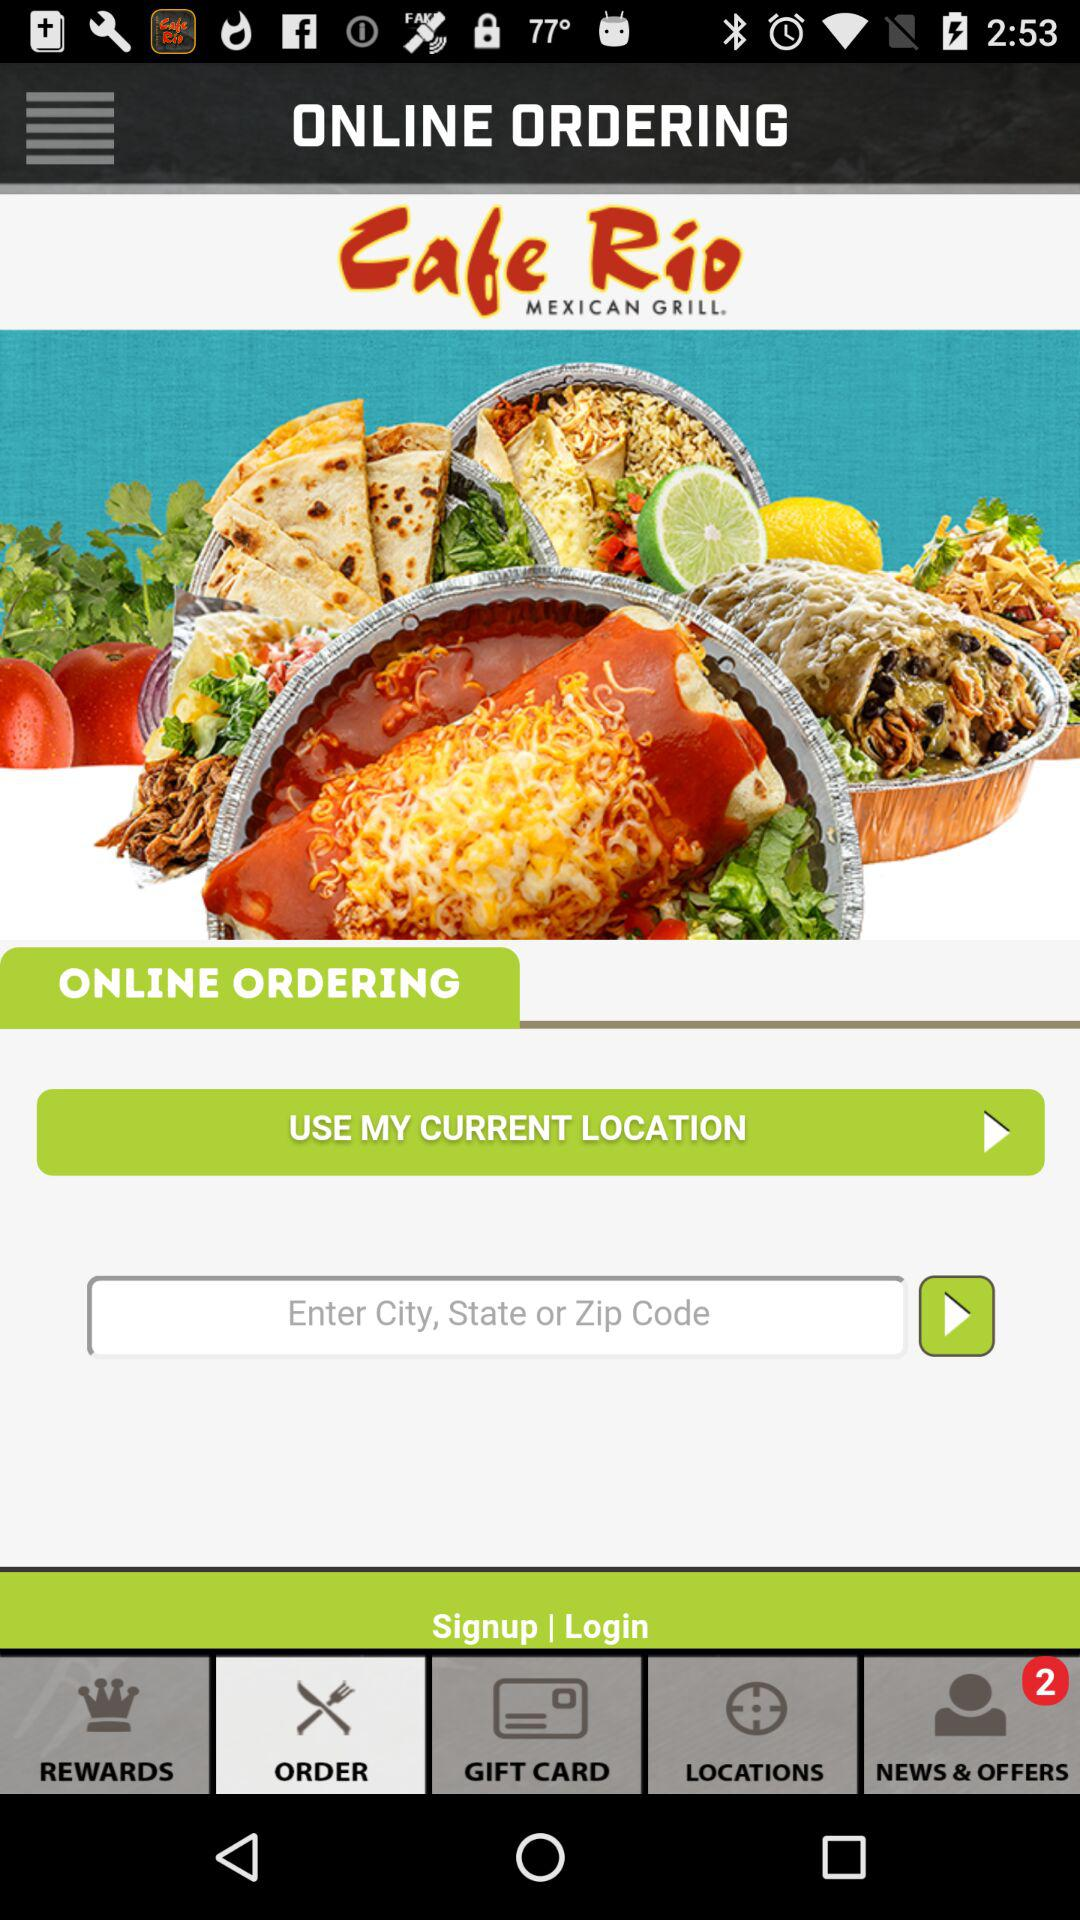Which location is chosen?
When the provided information is insufficient, respond with <no answer>. <no answer> 